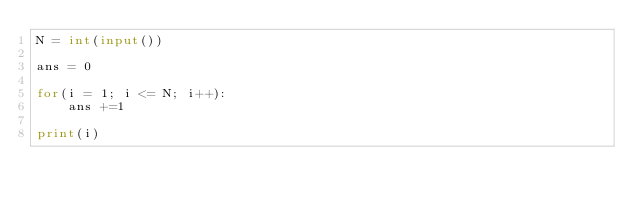Convert code to text. <code><loc_0><loc_0><loc_500><loc_500><_Python_>N = int(input())

ans = 0

for(i = 1; i <= N; i++):
    ans +=1

print(i)</code> 